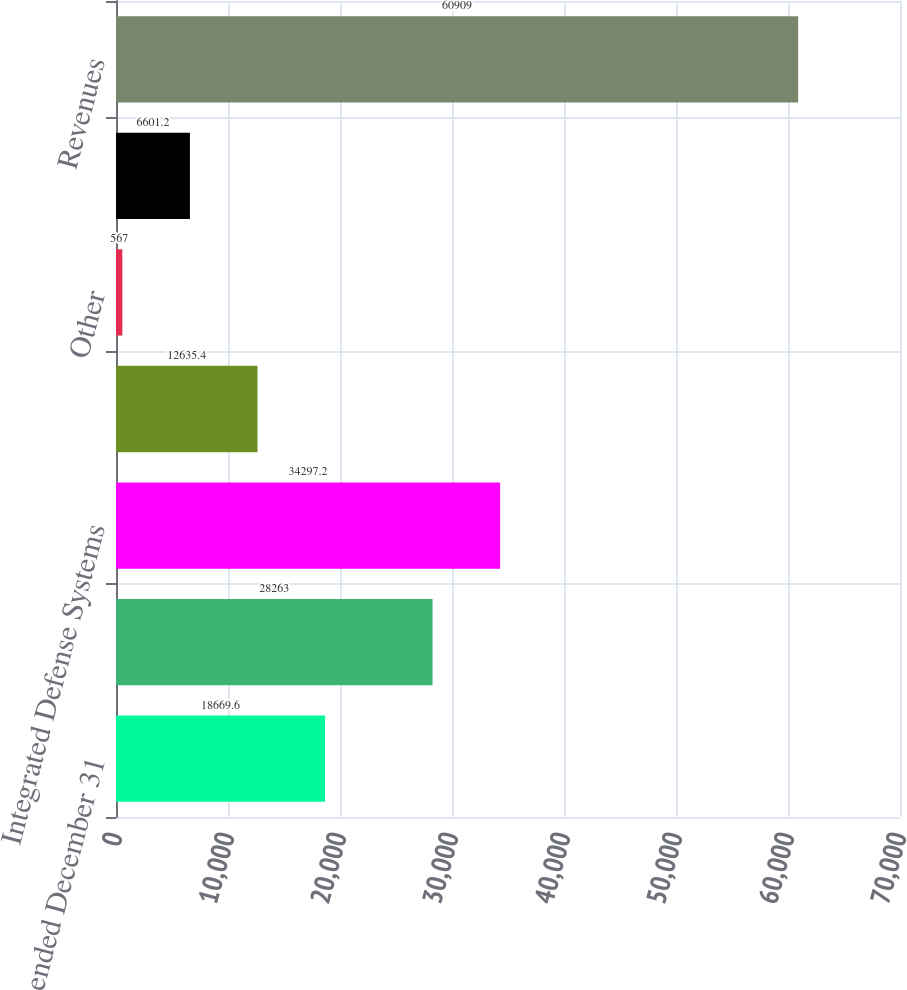<chart> <loc_0><loc_0><loc_500><loc_500><bar_chart><fcel>Years ended December 31<fcel>Commercial Airplanes<fcel>Integrated Defense Systems<fcel>Boeing Capital Corporation<fcel>Other<fcel>Unallocated items and<fcel>Revenues<nl><fcel>18669.6<fcel>28263<fcel>34297.2<fcel>12635.4<fcel>567<fcel>6601.2<fcel>60909<nl></chart> 